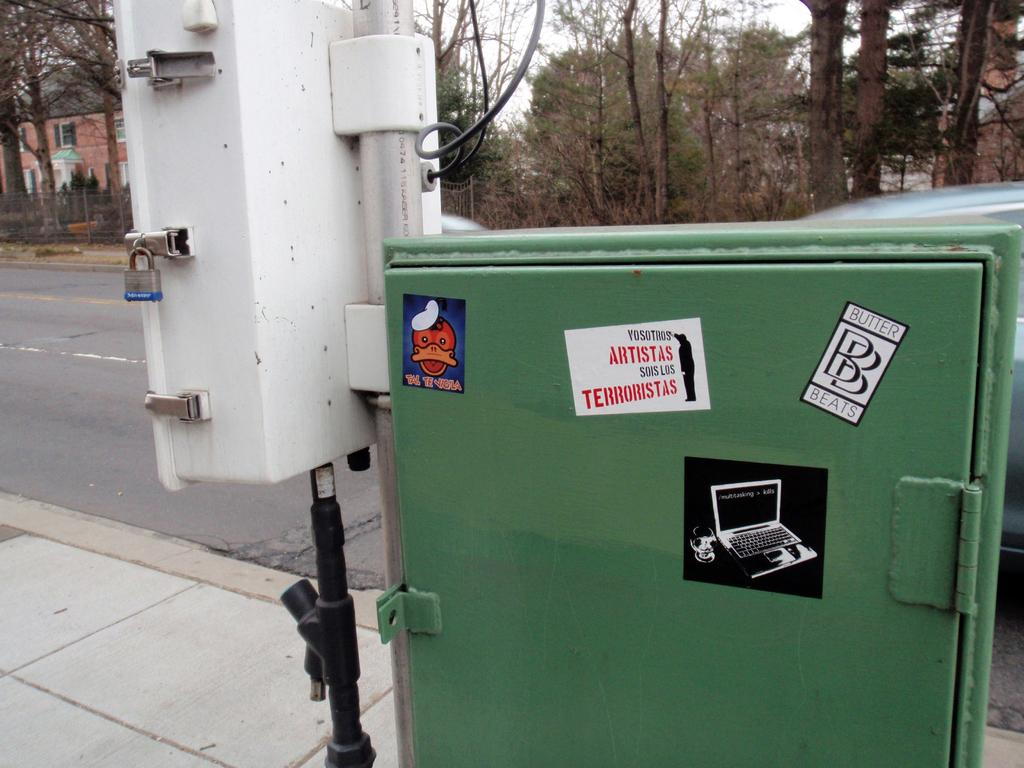What is the main object in the center of the image? There is a main board and a current pole in the center of the image. What can be seen in the background of the image? There are cars, trees, buildings, and the sky visible in the background of the image. Where are the ants carrying fruit in the image? There are no ants or fruit present in the image. What type of care is being provided to the main board in the image? The main board does not require care in the image; it is a stationary object. 